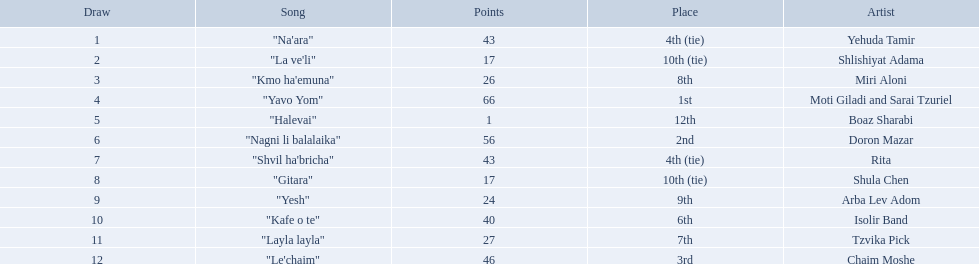Who were all the artists at the contest? Yehuda Tamir, Shlishiyat Adama, Miri Aloni, Moti Giladi and Sarai Tzuriel, Boaz Sharabi, Doron Mazar, Rita, Shula Chen, Arba Lev Adom, Isolir Band, Tzvika Pick, Chaim Moshe. What were their point totals? 43, 17, 26, 66, 1, 56, 43, 17, 24, 40, 27, 46. Of these, which is the least amount of points? 1. Which artists received this point total? Boaz Sharabi. 